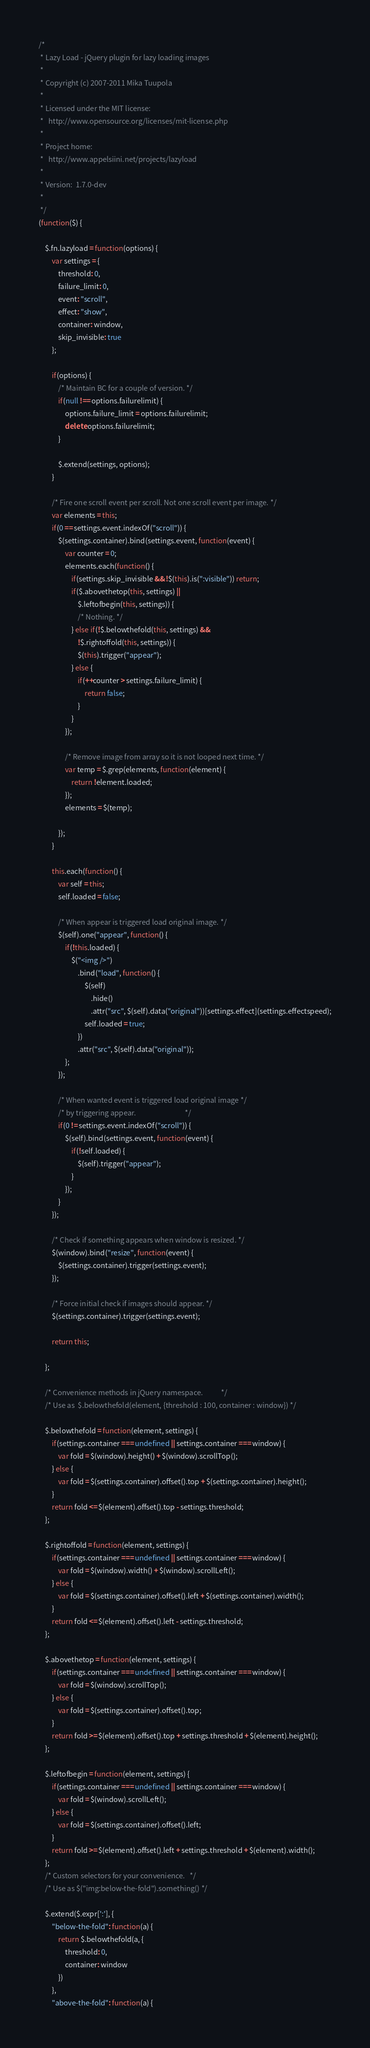Convert code to text. <code><loc_0><loc_0><loc_500><loc_500><_JavaScript_>/*
 * Lazy Load - jQuery plugin for lazy loading images
 *
 * Copyright (c) 2007-2011 Mika Tuupola
 *
 * Licensed under the MIT license:
 *   http://www.opensource.org/licenses/mit-license.php
 *
 * Project home:
 *   http://www.appelsiini.net/projects/lazyload
 *
 * Version:  1.7.0-dev
 *
 */
(function($) {

	$.fn.lazyload = function(options) {
		var settings = {
			threshold: 0,
			failure_limit: 0,
			event: "scroll",
			effect: "show",
			container: window,
			skip_invisible: true
		};

		if(options) {
			/* Maintain BC for a couple of version. */
			if(null !== options.failurelimit) {
				options.failure_limit = options.failurelimit;
				delete options.failurelimit;
			}

			$.extend(settings, options);
		}

		/* Fire one scroll event per scroll. Not one scroll event per image. */
		var elements = this;
		if(0 == settings.event.indexOf("scroll")) {
			$(settings.container).bind(settings.event, function(event) {
				var counter = 0;
				elements.each(function() {
					if(settings.skip_invisible && !$(this).is(":visible")) return;
					if($.abovethetop(this, settings) ||
						$.leftofbegin(this, settings)) {
						/* Nothing. */
					} else if(!$.belowthefold(this, settings) &&
						!$.rightoffold(this, settings)) {
						$(this).trigger("appear");
					} else {
						if(++counter > settings.failure_limit) {
							return false;
						}
					}
				});

				/* Remove image from array so it is not looped next time. */
				var temp = $.grep(elements, function(element) {
					return !element.loaded;
				});
				elements = $(temp);

			});
		}

		this.each(function() {
			var self = this;
			self.loaded = false;

			/* When appear is triggered load original image. */
			$(self).one("appear", function() {
				if(!this.loaded) {
					$("<img />")
						.bind("load", function() {
							$(self)
								.hide()
								.attr("src", $(self).data("original"))[settings.effect](settings.effectspeed);
							self.loaded = true;
						})
						.attr("src", $(self).data("original"));
				};
			});

			/* When wanted event is triggered load original image */
			/* by triggering appear.                              */
			if(0 != settings.event.indexOf("scroll")) {
				$(self).bind(settings.event, function(event) {
					if(!self.loaded) {
						$(self).trigger("appear");
					}
				});
			}
		});

		/* Check if something appears when window is resized. */
		$(window).bind("resize", function(event) {
			$(settings.container).trigger(settings.event);
		});

		/* Force initial check if images should appear. */
		$(settings.container).trigger(settings.event);

		return this;

	};

	/* Convenience methods in jQuery namespace.           */
	/* Use as  $.belowthefold(element, {threshold : 100, container : window}) */

	$.belowthefold = function(element, settings) {
		if(settings.container === undefined || settings.container === window) {
			var fold = $(window).height() + $(window).scrollTop();
		} else {
			var fold = $(settings.container).offset().top + $(settings.container).height();
		}
		return fold <= $(element).offset().top - settings.threshold;
	};

	$.rightoffold = function(element, settings) {
		if(settings.container === undefined || settings.container === window) {
			var fold = $(window).width() + $(window).scrollLeft();
		} else {
			var fold = $(settings.container).offset().left + $(settings.container).width();
		}
		return fold <= $(element).offset().left - settings.threshold;
	};

	$.abovethetop = function(element, settings) {
		if(settings.container === undefined || settings.container === window) {
			var fold = $(window).scrollTop();
		} else {
			var fold = $(settings.container).offset().top;
		}
		return fold >= $(element).offset().top + settings.threshold + $(element).height();
	};

	$.leftofbegin = function(element, settings) {
		if(settings.container === undefined || settings.container === window) {
			var fold = $(window).scrollLeft();
		} else {
			var fold = $(settings.container).offset().left;
		}
		return fold >= $(element).offset().left + settings.threshold + $(element).width();
	};
	/* Custom selectors for your convenience.   */
	/* Use as $("img:below-the-fold").something() */

	$.extend($.expr[':'], {
		"below-the-fold": function(a) {
			return $.belowthefold(a, {
				threshold: 0,
				container: window
			})
		},
		"above-the-fold": function(a) {</code> 